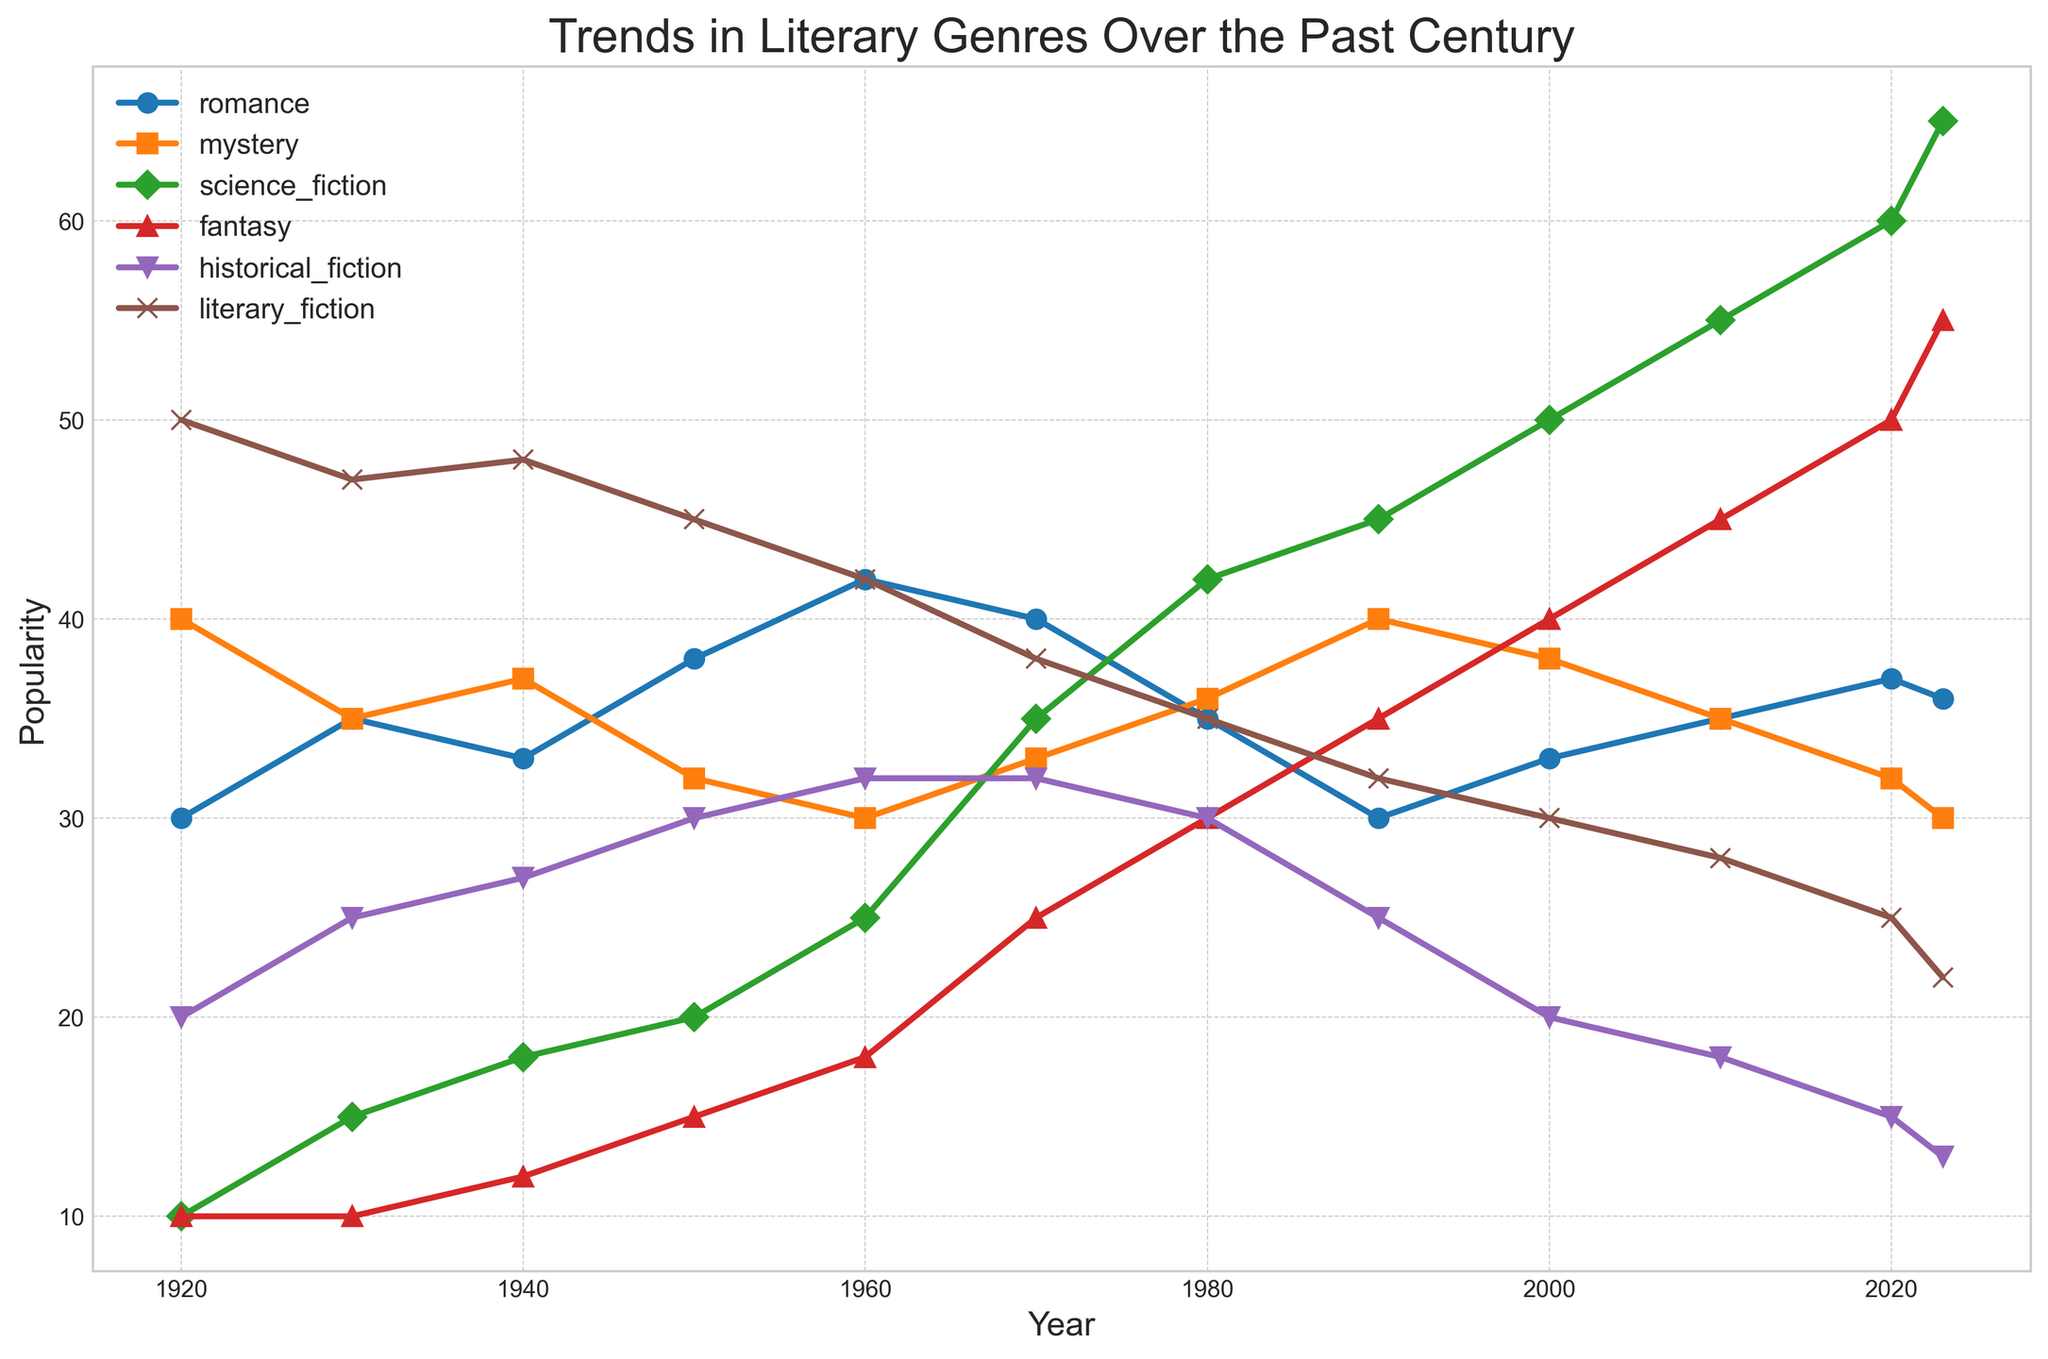What year did Romance and Mystery genres have the closest popularity? Based on the visual trends of the plots, find the two lines (Romance and Mystery) that get closest to each other. This happens in 1920 where Romance is at 30 and Mystery is at 40, and they intersect around 1960 when Romance is 42 and Mystery is 30. So the year they were closest was 1950.
Answer: 1950 Which genre showed the most consistent increase in popularity over the century? Observing the trends for consistency, Science Fiction shows an increasing trend from 1920 (10) to 2023 (65) without significant drops.
Answer: Science Fiction How did the popularity of Fantasy compare between 1980 and 2023? Look at the points between these years. Fantasy increased from 30 in 1980 to 55 in 2023, showing a clear upward trend.
Answer: Increased Which genre experienced the most significant decline in popularity since 1920? Compare the popularity values from 1920 to 2023 across all genres. Literary Fiction declined from 50 in 1920 to 22 in 2023.
Answer: Literary Fiction By how much did Historical Fiction's popularity change from 1920 to 2023? Subtract the 1920 value from the 2023 value for Historical Fiction. It dropped from 20 to 13, so 20 - 13 = 7.
Answer: 7 In what year did Romance, Mystery, and Science Fiction all have a relatively similar popularity level? Analyze the points where all three lines are closest. Around 1950, Romance is 38, Mystery is 32, and Science Fiction is 20, thus being relatively similar.
Answer: 1950 Were there any genres that maintained a relatively stable popularity over the past century? Literary Fiction shows relatively stable values fluctuating slightly between 25 to 50 throughout the century when observed on the plot.
Answer: Literary Fiction What is the difference in popularity between Fantasy and Historical Fiction in 2023? For 2023 values, Fantasy is 55 and Historical Fiction is 13. The difference is 55 - 13 = 42.
Answer: 42 When did Science Fiction surpass Romance in popularity for the first time? Locate the year where the Science Fiction line crosses above the Romance line. This starts occurring around 1970.
Answer: 1970 